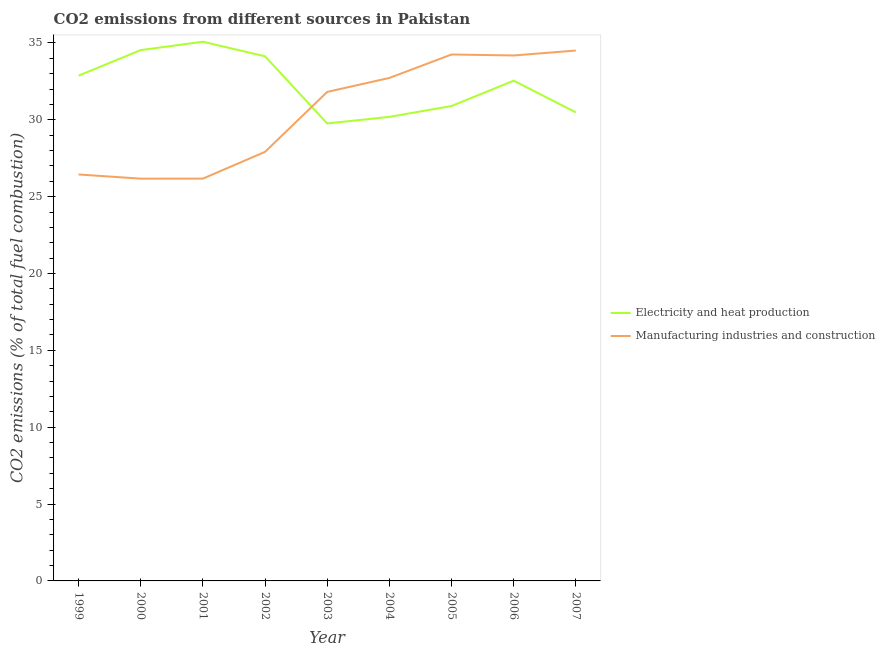How many different coloured lines are there?
Offer a terse response. 2. Is the number of lines equal to the number of legend labels?
Keep it short and to the point. Yes. What is the co2 emissions due to manufacturing industries in 2000?
Offer a very short reply. 26.17. Across all years, what is the maximum co2 emissions due to manufacturing industries?
Provide a short and direct response. 34.51. Across all years, what is the minimum co2 emissions due to electricity and heat production?
Offer a terse response. 29.76. In which year was the co2 emissions due to manufacturing industries maximum?
Give a very brief answer. 2007. In which year was the co2 emissions due to manufacturing industries minimum?
Give a very brief answer. 2000. What is the total co2 emissions due to manufacturing industries in the graph?
Your answer should be compact. 274.18. What is the difference between the co2 emissions due to manufacturing industries in 2000 and that in 2005?
Make the answer very short. -8.08. What is the difference between the co2 emissions due to manufacturing industries in 2007 and the co2 emissions due to electricity and heat production in 2006?
Keep it short and to the point. 1.96. What is the average co2 emissions due to electricity and heat production per year?
Give a very brief answer. 32.28. In the year 2002, what is the difference between the co2 emissions due to manufacturing industries and co2 emissions due to electricity and heat production?
Your answer should be very brief. -6.22. What is the ratio of the co2 emissions due to electricity and heat production in 2001 to that in 2002?
Your answer should be very brief. 1.03. Is the co2 emissions due to manufacturing industries in 2002 less than that in 2004?
Make the answer very short. Yes. Is the difference between the co2 emissions due to manufacturing industries in 2002 and 2004 greater than the difference between the co2 emissions due to electricity and heat production in 2002 and 2004?
Give a very brief answer. No. What is the difference between the highest and the second highest co2 emissions due to manufacturing industries?
Your response must be concise. 0.26. What is the difference between the highest and the lowest co2 emissions due to manufacturing industries?
Provide a short and direct response. 8.34. Is the sum of the co2 emissions due to manufacturing industries in 1999 and 2001 greater than the maximum co2 emissions due to electricity and heat production across all years?
Your answer should be compact. Yes. Does the co2 emissions due to manufacturing industries monotonically increase over the years?
Your response must be concise. No. Is the co2 emissions due to electricity and heat production strictly greater than the co2 emissions due to manufacturing industries over the years?
Provide a succinct answer. No. Is the co2 emissions due to manufacturing industries strictly less than the co2 emissions due to electricity and heat production over the years?
Your answer should be very brief. No. What is the difference between two consecutive major ticks on the Y-axis?
Give a very brief answer. 5. What is the title of the graph?
Offer a terse response. CO2 emissions from different sources in Pakistan. Does "Working only" appear as one of the legend labels in the graph?
Give a very brief answer. No. What is the label or title of the Y-axis?
Your response must be concise. CO2 emissions (% of total fuel combustion). What is the CO2 emissions (% of total fuel combustion) of Electricity and heat production in 1999?
Offer a very short reply. 32.87. What is the CO2 emissions (% of total fuel combustion) of Manufacturing industries and construction in 1999?
Your answer should be very brief. 26.44. What is the CO2 emissions (% of total fuel combustion) in Electricity and heat production in 2000?
Your answer should be compact. 34.54. What is the CO2 emissions (% of total fuel combustion) of Manufacturing industries and construction in 2000?
Provide a succinct answer. 26.17. What is the CO2 emissions (% of total fuel combustion) of Electricity and heat production in 2001?
Provide a succinct answer. 35.08. What is the CO2 emissions (% of total fuel combustion) in Manufacturing industries and construction in 2001?
Make the answer very short. 26.17. What is the CO2 emissions (% of total fuel combustion) of Electricity and heat production in 2002?
Provide a short and direct response. 34.13. What is the CO2 emissions (% of total fuel combustion) in Manufacturing industries and construction in 2002?
Your answer should be very brief. 27.91. What is the CO2 emissions (% of total fuel combustion) of Electricity and heat production in 2003?
Make the answer very short. 29.76. What is the CO2 emissions (% of total fuel combustion) in Manufacturing industries and construction in 2003?
Make the answer very short. 31.81. What is the CO2 emissions (% of total fuel combustion) in Electricity and heat production in 2004?
Offer a very short reply. 30.19. What is the CO2 emissions (% of total fuel combustion) of Manufacturing industries and construction in 2004?
Offer a very short reply. 32.72. What is the CO2 emissions (% of total fuel combustion) of Electricity and heat production in 2005?
Your answer should be very brief. 30.9. What is the CO2 emissions (% of total fuel combustion) of Manufacturing industries and construction in 2005?
Your answer should be compact. 34.25. What is the CO2 emissions (% of total fuel combustion) of Electricity and heat production in 2006?
Your answer should be compact. 32.55. What is the CO2 emissions (% of total fuel combustion) of Manufacturing industries and construction in 2006?
Keep it short and to the point. 34.19. What is the CO2 emissions (% of total fuel combustion) in Electricity and heat production in 2007?
Provide a short and direct response. 30.48. What is the CO2 emissions (% of total fuel combustion) in Manufacturing industries and construction in 2007?
Your answer should be very brief. 34.51. Across all years, what is the maximum CO2 emissions (% of total fuel combustion) in Electricity and heat production?
Make the answer very short. 35.08. Across all years, what is the maximum CO2 emissions (% of total fuel combustion) of Manufacturing industries and construction?
Provide a succinct answer. 34.51. Across all years, what is the minimum CO2 emissions (% of total fuel combustion) of Electricity and heat production?
Provide a succinct answer. 29.76. Across all years, what is the minimum CO2 emissions (% of total fuel combustion) of Manufacturing industries and construction?
Ensure brevity in your answer.  26.17. What is the total CO2 emissions (% of total fuel combustion) of Electricity and heat production in the graph?
Your response must be concise. 290.5. What is the total CO2 emissions (% of total fuel combustion) in Manufacturing industries and construction in the graph?
Your answer should be very brief. 274.18. What is the difference between the CO2 emissions (% of total fuel combustion) in Electricity and heat production in 1999 and that in 2000?
Provide a short and direct response. -1.66. What is the difference between the CO2 emissions (% of total fuel combustion) of Manufacturing industries and construction in 1999 and that in 2000?
Ensure brevity in your answer.  0.27. What is the difference between the CO2 emissions (% of total fuel combustion) in Electricity and heat production in 1999 and that in 2001?
Your answer should be compact. -2.21. What is the difference between the CO2 emissions (% of total fuel combustion) of Manufacturing industries and construction in 1999 and that in 2001?
Offer a terse response. 0.27. What is the difference between the CO2 emissions (% of total fuel combustion) of Electricity and heat production in 1999 and that in 2002?
Your response must be concise. -1.26. What is the difference between the CO2 emissions (% of total fuel combustion) of Manufacturing industries and construction in 1999 and that in 2002?
Provide a succinct answer. -1.47. What is the difference between the CO2 emissions (% of total fuel combustion) in Electricity and heat production in 1999 and that in 2003?
Make the answer very short. 3.11. What is the difference between the CO2 emissions (% of total fuel combustion) of Manufacturing industries and construction in 1999 and that in 2003?
Keep it short and to the point. -5.37. What is the difference between the CO2 emissions (% of total fuel combustion) in Electricity and heat production in 1999 and that in 2004?
Provide a succinct answer. 2.68. What is the difference between the CO2 emissions (% of total fuel combustion) in Manufacturing industries and construction in 1999 and that in 2004?
Keep it short and to the point. -6.28. What is the difference between the CO2 emissions (% of total fuel combustion) in Electricity and heat production in 1999 and that in 2005?
Give a very brief answer. 1.98. What is the difference between the CO2 emissions (% of total fuel combustion) in Manufacturing industries and construction in 1999 and that in 2005?
Make the answer very short. -7.8. What is the difference between the CO2 emissions (% of total fuel combustion) of Electricity and heat production in 1999 and that in 2006?
Offer a very short reply. 0.33. What is the difference between the CO2 emissions (% of total fuel combustion) of Manufacturing industries and construction in 1999 and that in 2006?
Offer a very short reply. -7.74. What is the difference between the CO2 emissions (% of total fuel combustion) of Electricity and heat production in 1999 and that in 2007?
Provide a short and direct response. 2.39. What is the difference between the CO2 emissions (% of total fuel combustion) of Manufacturing industries and construction in 1999 and that in 2007?
Your response must be concise. -8.06. What is the difference between the CO2 emissions (% of total fuel combustion) of Electricity and heat production in 2000 and that in 2001?
Keep it short and to the point. -0.54. What is the difference between the CO2 emissions (% of total fuel combustion) in Manufacturing industries and construction in 2000 and that in 2001?
Provide a short and direct response. -0. What is the difference between the CO2 emissions (% of total fuel combustion) of Electricity and heat production in 2000 and that in 2002?
Your response must be concise. 0.4. What is the difference between the CO2 emissions (% of total fuel combustion) of Manufacturing industries and construction in 2000 and that in 2002?
Keep it short and to the point. -1.74. What is the difference between the CO2 emissions (% of total fuel combustion) of Electricity and heat production in 2000 and that in 2003?
Offer a very short reply. 4.77. What is the difference between the CO2 emissions (% of total fuel combustion) in Manufacturing industries and construction in 2000 and that in 2003?
Make the answer very short. -5.64. What is the difference between the CO2 emissions (% of total fuel combustion) of Electricity and heat production in 2000 and that in 2004?
Offer a very short reply. 4.34. What is the difference between the CO2 emissions (% of total fuel combustion) in Manufacturing industries and construction in 2000 and that in 2004?
Your answer should be compact. -6.55. What is the difference between the CO2 emissions (% of total fuel combustion) of Electricity and heat production in 2000 and that in 2005?
Your response must be concise. 3.64. What is the difference between the CO2 emissions (% of total fuel combustion) in Manufacturing industries and construction in 2000 and that in 2005?
Provide a short and direct response. -8.08. What is the difference between the CO2 emissions (% of total fuel combustion) of Electricity and heat production in 2000 and that in 2006?
Keep it short and to the point. 1.99. What is the difference between the CO2 emissions (% of total fuel combustion) of Manufacturing industries and construction in 2000 and that in 2006?
Make the answer very short. -8.01. What is the difference between the CO2 emissions (% of total fuel combustion) in Electricity and heat production in 2000 and that in 2007?
Make the answer very short. 4.05. What is the difference between the CO2 emissions (% of total fuel combustion) of Manufacturing industries and construction in 2000 and that in 2007?
Offer a very short reply. -8.34. What is the difference between the CO2 emissions (% of total fuel combustion) in Electricity and heat production in 2001 and that in 2002?
Provide a succinct answer. 0.95. What is the difference between the CO2 emissions (% of total fuel combustion) in Manufacturing industries and construction in 2001 and that in 2002?
Provide a short and direct response. -1.74. What is the difference between the CO2 emissions (% of total fuel combustion) in Electricity and heat production in 2001 and that in 2003?
Provide a short and direct response. 5.32. What is the difference between the CO2 emissions (% of total fuel combustion) in Manufacturing industries and construction in 2001 and that in 2003?
Your answer should be compact. -5.64. What is the difference between the CO2 emissions (% of total fuel combustion) of Electricity and heat production in 2001 and that in 2004?
Provide a succinct answer. 4.89. What is the difference between the CO2 emissions (% of total fuel combustion) of Manufacturing industries and construction in 2001 and that in 2004?
Your answer should be compact. -6.55. What is the difference between the CO2 emissions (% of total fuel combustion) in Electricity and heat production in 2001 and that in 2005?
Offer a very short reply. 4.18. What is the difference between the CO2 emissions (% of total fuel combustion) in Manufacturing industries and construction in 2001 and that in 2005?
Your answer should be very brief. -8.08. What is the difference between the CO2 emissions (% of total fuel combustion) in Electricity and heat production in 2001 and that in 2006?
Give a very brief answer. 2.53. What is the difference between the CO2 emissions (% of total fuel combustion) in Manufacturing industries and construction in 2001 and that in 2006?
Give a very brief answer. -8.01. What is the difference between the CO2 emissions (% of total fuel combustion) of Electricity and heat production in 2001 and that in 2007?
Your answer should be very brief. 4.6. What is the difference between the CO2 emissions (% of total fuel combustion) of Manufacturing industries and construction in 2001 and that in 2007?
Offer a very short reply. -8.33. What is the difference between the CO2 emissions (% of total fuel combustion) in Electricity and heat production in 2002 and that in 2003?
Ensure brevity in your answer.  4.37. What is the difference between the CO2 emissions (% of total fuel combustion) in Manufacturing industries and construction in 2002 and that in 2003?
Offer a terse response. -3.9. What is the difference between the CO2 emissions (% of total fuel combustion) of Electricity and heat production in 2002 and that in 2004?
Offer a very short reply. 3.94. What is the difference between the CO2 emissions (% of total fuel combustion) of Manufacturing industries and construction in 2002 and that in 2004?
Your answer should be compact. -4.81. What is the difference between the CO2 emissions (% of total fuel combustion) in Electricity and heat production in 2002 and that in 2005?
Give a very brief answer. 3.23. What is the difference between the CO2 emissions (% of total fuel combustion) of Manufacturing industries and construction in 2002 and that in 2005?
Your response must be concise. -6.33. What is the difference between the CO2 emissions (% of total fuel combustion) of Electricity and heat production in 2002 and that in 2006?
Provide a succinct answer. 1.59. What is the difference between the CO2 emissions (% of total fuel combustion) of Manufacturing industries and construction in 2002 and that in 2006?
Offer a terse response. -6.27. What is the difference between the CO2 emissions (% of total fuel combustion) in Electricity and heat production in 2002 and that in 2007?
Give a very brief answer. 3.65. What is the difference between the CO2 emissions (% of total fuel combustion) in Manufacturing industries and construction in 2002 and that in 2007?
Your response must be concise. -6.59. What is the difference between the CO2 emissions (% of total fuel combustion) of Electricity and heat production in 2003 and that in 2004?
Your answer should be very brief. -0.43. What is the difference between the CO2 emissions (% of total fuel combustion) of Manufacturing industries and construction in 2003 and that in 2004?
Provide a succinct answer. -0.91. What is the difference between the CO2 emissions (% of total fuel combustion) of Electricity and heat production in 2003 and that in 2005?
Your answer should be compact. -1.13. What is the difference between the CO2 emissions (% of total fuel combustion) of Manufacturing industries and construction in 2003 and that in 2005?
Your answer should be very brief. -2.43. What is the difference between the CO2 emissions (% of total fuel combustion) in Electricity and heat production in 2003 and that in 2006?
Offer a very short reply. -2.78. What is the difference between the CO2 emissions (% of total fuel combustion) in Manufacturing industries and construction in 2003 and that in 2006?
Offer a very short reply. -2.37. What is the difference between the CO2 emissions (% of total fuel combustion) in Electricity and heat production in 2003 and that in 2007?
Make the answer very short. -0.72. What is the difference between the CO2 emissions (% of total fuel combustion) in Manufacturing industries and construction in 2003 and that in 2007?
Offer a very short reply. -2.69. What is the difference between the CO2 emissions (% of total fuel combustion) of Electricity and heat production in 2004 and that in 2005?
Offer a very short reply. -0.7. What is the difference between the CO2 emissions (% of total fuel combustion) in Manufacturing industries and construction in 2004 and that in 2005?
Your answer should be compact. -1.53. What is the difference between the CO2 emissions (% of total fuel combustion) of Electricity and heat production in 2004 and that in 2006?
Offer a very short reply. -2.35. What is the difference between the CO2 emissions (% of total fuel combustion) in Manufacturing industries and construction in 2004 and that in 2006?
Offer a terse response. -1.46. What is the difference between the CO2 emissions (% of total fuel combustion) in Electricity and heat production in 2004 and that in 2007?
Your response must be concise. -0.29. What is the difference between the CO2 emissions (% of total fuel combustion) in Manufacturing industries and construction in 2004 and that in 2007?
Your answer should be very brief. -1.78. What is the difference between the CO2 emissions (% of total fuel combustion) of Electricity and heat production in 2005 and that in 2006?
Provide a succinct answer. -1.65. What is the difference between the CO2 emissions (% of total fuel combustion) in Manufacturing industries and construction in 2005 and that in 2006?
Keep it short and to the point. 0.06. What is the difference between the CO2 emissions (% of total fuel combustion) of Electricity and heat production in 2005 and that in 2007?
Your response must be concise. 0.41. What is the difference between the CO2 emissions (% of total fuel combustion) in Manufacturing industries and construction in 2005 and that in 2007?
Provide a succinct answer. -0.26. What is the difference between the CO2 emissions (% of total fuel combustion) of Electricity and heat production in 2006 and that in 2007?
Your response must be concise. 2.06. What is the difference between the CO2 emissions (% of total fuel combustion) of Manufacturing industries and construction in 2006 and that in 2007?
Provide a succinct answer. -0.32. What is the difference between the CO2 emissions (% of total fuel combustion) of Electricity and heat production in 1999 and the CO2 emissions (% of total fuel combustion) of Manufacturing industries and construction in 2000?
Your response must be concise. 6.7. What is the difference between the CO2 emissions (% of total fuel combustion) in Electricity and heat production in 1999 and the CO2 emissions (% of total fuel combustion) in Manufacturing industries and construction in 2001?
Make the answer very short. 6.7. What is the difference between the CO2 emissions (% of total fuel combustion) of Electricity and heat production in 1999 and the CO2 emissions (% of total fuel combustion) of Manufacturing industries and construction in 2002?
Provide a short and direct response. 4.96. What is the difference between the CO2 emissions (% of total fuel combustion) of Electricity and heat production in 1999 and the CO2 emissions (% of total fuel combustion) of Manufacturing industries and construction in 2003?
Offer a terse response. 1.06. What is the difference between the CO2 emissions (% of total fuel combustion) of Electricity and heat production in 1999 and the CO2 emissions (% of total fuel combustion) of Manufacturing industries and construction in 2004?
Your answer should be compact. 0.15. What is the difference between the CO2 emissions (% of total fuel combustion) in Electricity and heat production in 1999 and the CO2 emissions (% of total fuel combustion) in Manufacturing industries and construction in 2005?
Offer a very short reply. -1.38. What is the difference between the CO2 emissions (% of total fuel combustion) of Electricity and heat production in 1999 and the CO2 emissions (% of total fuel combustion) of Manufacturing industries and construction in 2006?
Offer a very short reply. -1.31. What is the difference between the CO2 emissions (% of total fuel combustion) of Electricity and heat production in 1999 and the CO2 emissions (% of total fuel combustion) of Manufacturing industries and construction in 2007?
Your answer should be compact. -1.63. What is the difference between the CO2 emissions (% of total fuel combustion) in Electricity and heat production in 2000 and the CO2 emissions (% of total fuel combustion) in Manufacturing industries and construction in 2001?
Make the answer very short. 8.36. What is the difference between the CO2 emissions (% of total fuel combustion) in Electricity and heat production in 2000 and the CO2 emissions (% of total fuel combustion) in Manufacturing industries and construction in 2002?
Your answer should be compact. 6.62. What is the difference between the CO2 emissions (% of total fuel combustion) of Electricity and heat production in 2000 and the CO2 emissions (% of total fuel combustion) of Manufacturing industries and construction in 2003?
Provide a succinct answer. 2.72. What is the difference between the CO2 emissions (% of total fuel combustion) of Electricity and heat production in 2000 and the CO2 emissions (% of total fuel combustion) of Manufacturing industries and construction in 2004?
Keep it short and to the point. 1.81. What is the difference between the CO2 emissions (% of total fuel combustion) in Electricity and heat production in 2000 and the CO2 emissions (% of total fuel combustion) in Manufacturing industries and construction in 2005?
Provide a succinct answer. 0.29. What is the difference between the CO2 emissions (% of total fuel combustion) of Electricity and heat production in 2000 and the CO2 emissions (% of total fuel combustion) of Manufacturing industries and construction in 2006?
Your answer should be very brief. 0.35. What is the difference between the CO2 emissions (% of total fuel combustion) of Electricity and heat production in 2000 and the CO2 emissions (% of total fuel combustion) of Manufacturing industries and construction in 2007?
Ensure brevity in your answer.  0.03. What is the difference between the CO2 emissions (% of total fuel combustion) in Electricity and heat production in 2001 and the CO2 emissions (% of total fuel combustion) in Manufacturing industries and construction in 2002?
Provide a succinct answer. 7.17. What is the difference between the CO2 emissions (% of total fuel combustion) of Electricity and heat production in 2001 and the CO2 emissions (% of total fuel combustion) of Manufacturing industries and construction in 2003?
Offer a very short reply. 3.27. What is the difference between the CO2 emissions (% of total fuel combustion) in Electricity and heat production in 2001 and the CO2 emissions (% of total fuel combustion) in Manufacturing industries and construction in 2004?
Offer a terse response. 2.36. What is the difference between the CO2 emissions (% of total fuel combustion) in Electricity and heat production in 2001 and the CO2 emissions (% of total fuel combustion) in Manufacturing industries and construction in 2005?
Offer a terse response. 0.83. What is the difference between the CO2 emissions (% of total fuel combustion) in Electricity and heat production in 2001 and the CO2 emissions (% of total fuel combustion) in Manufacturing industries and construction in 2006?
Your answer should be very brief. 0.89. What is the difference between the CO2 emissions (% of total fuel combustion) of Electricity and heat production in 2001 and the CO2 emissions (% of total fuel combustion) of Manufacturing industries and construction in 2007?
Make the answer very short. 0.57. What is the difference between the CO2 emissions (% of total fuel combustion) of Electricity and heat production in 2002 and the CO2 emissions (% of total fuel combustion) of Manufacturing industries and construction in 2003?
Give a very brief answer. 2.32. What is the difference between the CO2 emissions (% of total fuel combustion) of Electricity and heat production in 2002 and the CO2 emissions (% of total fuel combustion) of Manufacturing industries and construction in 2004?
Offer a very short reply. 1.41. What is the difference between the CO2 emissions (% of total fuel combustion) in Electricity and heat production in 2002 and the CO2 emissions (% of total fuel combustion) in Manufacturing industries and construction in 2005?
Offer a terse response. -0.12. What is the difference between the CO2 emissions (% of total fuel combustion) in Electricity and heat production in 2002 and the CO2 emissions (% of total fuel combustion) in Manufacturing industries and construction in 2006?
Provide a succinct answer. -0.05. What is the difference between the CO2 emissions (% of total fuel combustion) of Electricity and heat production in 2002 and the CO2 emissions (% of total fuel combustion) of Manufacturing industries and construction in 2007?
Provide a short and direct response. -0.38. What is the difference between the CO2 emissions (% of total fuel combustion) in Electricity and heat production in 2003 and the CO2 emissions (% of total fuel combustion) in Manufacturing industries and construction in 2004?
Give a very brief answer. -2.96. What is the difference between the CO2 emissions (% of total fuel combustion) in Electricity and heat production in 2003 and the CO2 emissions (% of total fuel combustion) in Manufacturing industries and construction in 2005?
Keep it short and to the point. -4.49. What is the difference between the CO2 emissions (% of total fuel combustion) of Electricity and heat production in 2003 and the CO2 emissions (% of total fuel combustion) of Manufacturing industries and construction in 2006?
Make the answer very short. -4.42. What is the difference between the CO2 emissions (% of total fuel combustion) of Electricity and heat production in 2003 and the CO2 emissions (% of total fuel combustion) of Manufacturing industries and construction in 2007?
Ensure brevity in your answer.  -4.74. What is the difference between the CO2 emissions (% of total fuel combustion) in Electricity and heat production in 2004 and the CO2 emissions (% of total fuel combustion) in Manufacturing industries and construction in 2005?
Ensure brevity in your answer.  -4.06. What is the difference between the CO2 emissions (% of total fuel combustion) in Electricity and heat production in 2004 and the CO2 emissions (% of total fuel combustion) in Manufacturing industries and construction in 2006?
Offer a terse response. -3.99. What is the difference between the CO2 emissions (% of total fuel combustion) in Electricity and heat production in 2004 and the CO2 emissions (% of total fuel combustion) in Manufacturing industries and construction in 2007?
Offer a very short reply. -4.32. What is the difference between the CO2 emissions (% of total fuel combustion) of Electricity and heat production in 2005 and the CO2 emissions (% of total fuel combustion) of Manufacturing industries and construction in 2006?
Ensure brevity in your answer.  -3.29. What is the difference between the CO2 emissions (% of total fuel combustion) of Electricity and heat production in 2005 and the CO2 emissions (% of total fuel combustion) of Manufacturing industries and construction in 2007?
Provide a short and direct response. -3.61. What is the difference between the CO2 emissions (% of total fuel combustion) of Electricity and heat production in 2006 and the CO2 emissions (% of total fuel combustion) of Manufacturing industries and construction in 2007?
Provide a short and direct response. -1.96. What is the average CO2 emissions (% of total fuel combustion) of Electricity and heat production per year?
Provide a succinct answer. 32.28. What is the average CO2 emissions (% of total fuel combustion) of Manufacturing industries and construction per year?
Your response must be concise. 30.46. In the year 1999, what is the difference between the CO2 emissions (% of total fuel combustion) of Electricity and heat production and CO2 emissions (% of total fuel combustion) of Manufacturing industries and construction?
Offer a terse response. 6.43. In the year 2000, what is the difference between the CO2 emissions (% of total fuel combustion) in Electricity and heat production and CO2 emissions (% of total fuel combustion) in Manufacturing industries and construction?
Make the answer very short. 8.36. In the year 2001, what is the difference between the CO2 emissions (% of total fuel combustion) of Electricity and heat production and CO2 emissions (% of total fuel combustion) of Manufacturing industries and construction?
Your answer should be compact. 8.91. In the year 2002, what is the difference between the CO2 emissions (% of total fuel combustion) in Electricity and heat production and CO2 emissions (% of total fuel combustion) in Manufacturing industries and construction?
Provide a succinct answer. 6.22. In the year 2003, what is the difference between the CO2 emissions (% of total fuel combustion) in Electricity and heat production and CO2 emissions (% of total fuel combustion) in Manufacturing industries and construction?
Provide a succinct answer. -2.05. In the year 2004, what is the difference between the CO2 emissions (% of total fuel combustion) in Electricity and heat production and CO2 emissions (% of total fuel combustion) in Manufacturing industries and construction?
Ensure brevity in your answer.  -2.53. In the year 2005, what is the difference between the CO2 emissions (% of total fuel combustion) of Electricity and heat production and CO2 emissions (% of total fuel combustion) of Manufacturing industries and construction?
Ensure brevity in your answer.  -3.35. In the year 2006, what is the difference between the CO2 emissions (% of total fuel combustion) of Electricity and heat production and CO2 emissions (% of total fuel combustion) of Manufacturing industries and construction?
Provide a short and direct response. -1.64. In the year 2007, what is the difference between the CO2 emissions (% of total fuel combustion) of Electricity and heat production and CO2 emissions (% of total fuel combustion) of Manufacturing industries and construction?
Give a very brief answer. -4.02. What is the ratio of the CO2 emissions (% of total fuel combustion) of Electricity and heat production in 1999 to that in 2000?
Your answer should be compact. 0.95. What is the ratio of the CO2 emissions (% of total fuel combustion) in Manufacturing industries and construction in 1999 to that in 2000?
Your answer should be very brief. 1.01. What is the ratio of the CO2 emissions (% of total fuel combustion) of Electricity and heat production in 1999 to that in 2001?
Ensure brevity in your answer.  0.94. What is the ratio of the CO2 emissions (% of total fuel combustion) of Manufacturing industries and construction in 1999 to that in 2001?
Offer a terse response. 1.01. What is the ratio of the CO2 emissions (% of total fuel combustion) in Electricity and heat production in 1999 to that in 2002?
Your response must be concise. 0.96. What is the ratio of the CO2 emissions (% of total fuel combustion) in Manufacturing industries and construction in 1999 to that in 2002?
Offer a very short reply. 0.95. What is the ratio of the CO2 emissions (% of total fuel combustion) in Electricity and heat production in 1999 to that in 2003?
Make the answer very short. 1.1. What is the ratio of the CO2 emissions (% of total fuel combustion) of Manufacturing industries and construction in 1999 to that in 2003?
Offer a terse response. 0.83. What is the ratio of the CO2 emissions (% of total fuel combustion) of Electricity and heat production in 1999 to that in 2004?
Give a very brief answer. 1.09. What is the ratio of the CO2 emissions (% of total fuel combustion) of Manufacturing industries and construction in 1999 to that in 2004?
Make the answer very short. 0.81. What is the ratio of the CO2 emissions (% of total fuel combustion) in Electricity and heat production in 1999 to that in 2005?
Offer a terse response. 1.06. What is the ratio of the CO2 emissions (% of total fuel combustion) of Manufacturing industries and construction in 1999 to that in 2005?
Ensure brevity in your answer.  0.77. What is the ratio of the CO2 emissions (% of total fuel combustion) in Electricity and heat production in 1999 to that in 2006?
Offer a very short reply. 1.01. What is the ratio of the CO2 emissions (% of total fuel combustion) of Manufacturing industries and construction in 1999 to that in 2006?
Keep it short and to the point. 0.77. What is the ratio of the CO2 emissions (% of total fuel combustion) in Electricity and heat production in 1999 to that in 2007?
Your answer should be compact. 1.08. What is the ratio of the CO2 emissions (% of total fuel combustion) of Manufacturing industries and construction in 1999 to that in 2007?
Offer a terse response. 0.77. What is the ratio of the CO2 emissions (% of total fuel combustion) in Electricity and heat production in 2000 to that in 2001?
Provide a succinct answer. 0.98. What is the ratio of the CO2 emissions (% of total fuel combustion) of Manufacturing industries and construction in 2000 to that in 2001?
Provide a succinct answer. 1. What is the ratio of the CO2 emissions (% of total fuel combustion) of Electricity and heat production in 2000 to that in 2002?
Provide a succinct answer. 1.01. What is the ratio of the CO2 emissions (% of total fuel combustion) in Manufacturing industries and construction in 2000 to that in 2002?
Give a very brief answer. 0.94. What is the ratio of the CO2 emissions (% of total fuel combustion) in Electricity and heat production in 2000 to that in 2003?
Make the answer very short. 1.16. What is the ratio of the CO2 emissions (% of total fuel combustion) of Manufacturing industries and construction in 2000 to that in 2003?
Your answer should be compact. 0.82. What is the ratio of the CO2 emissions (% of total fuel combustion) of Electricity and heat production in 2000 to that in 2004?
Provide a succinct answer. 1.14. What is the ratio of the CO2 emissions (% of total fuel combustion) in Manufacturing industries and construction in 2000 to that in 2004?
Give a very brief answer. 0.8. What is the ratio of the CO2 emissions (% of total fuel combustion) in Electricity and heat production in 2000 to that in 2005?
Your response must be concise. 1.12. What is the ratio of the CO2 emissions (% of total fuel combustion) in Manufacturing industries and construction in 2000 to that in 2005?
Make the answer very short. 0.76. What is the ratio of the CO2 emissions (% of total fuel combustion) of Electricity and heat production in 2000 to that in 2006?
Keep it short and to the point. 1.06. What is the ratio of the CO2 emissions (% of total fuel combustion) in Manufacturing industries and construction in 2000 to that in 2006?
Keep it short and to the point. 0.77. What is the ratio of the CO2 emissions (% of total fuel combustion) of Electricity and heat production in 2000 to that in 2007?
Keep it short and to the point. 1.13. What is the ratio of the CO2 emissions (% of total fuel combustion) of Manufacturing industries and construction in 2000 to that in 2007?
Offer a terse response. 0.76. What is the ratio of the CO2 emissions (% of total fuel combustion) in Electricity and heat production in 2001 to that in 2002?
Ensure brevity in your answer.  1.03. What is the ratio of the CO2 emissions (% of total fuel combustion) of Manufacturing industries and construction in 2001 to that in 2002?
Your response must be concise. 0.94. What is the ratio of the CO2 emissions (% of total fuel combustion) of Electricity and heat production in 2001 to that in 2003?
Give a very brief answer. 1.18. What is the ratio of the CO2 emissions (% of total fuel combustion) in Manufacturing industries and construction in 2001 to that in 2003?
Give a very brief answer. 0.82. What is the ratio of the CO2 emissions (% of total fuel combustion) in Electricity and heat production in 2001 to that in 2004?
Provide a short and direct response. 1.16. What is the ratio of the CO2 emissions (% of total fuel combustion) in Manufacturing industries and construction in 2001 to that in 2004?
Provide a short and direct response. 0.8. What is the ratio of the CO2 emissions (% of total fuel combustion) of Electricity and heat production in 2001 to that in 2005?
Offer a terse response. 1.14. What is the ratio of the CO2 emissions (% of total fuel combustion) of Manufacturing industries and construction in 2001 to that in 2005?
Your answer should be compact. 0.76. What is the ratio of the CO2 emissions (% of total fuel combustion) of Electricity and heat production in 2001 to that in 2006?
Provide a succinct answer. 1.08. What is the ratio of the CO2 emissions (% of total fuel combustion) in Manufacturing industries and construction in 2001 to that in 2006?
Provide a short and direct response. 0.77. What is the ratio of the CO2 emissions (% of total fuel combustion) in Electricity and heat production in 2001 to that in 2007?
Provide a succinct answer. 1.15. What is the ratio of the CO2 emissions (% of total fuel combustion) of Manufacturing industries and construction in 2001 to that in 2007?
Keep it short and to the point. 0.76. What is the ratio of the CO2 emissions (% of total fuel combustion) of Electricity and heat production in 2002 to that in 2003?
Your answer should be very brief. 1.15. What is the ratio of the CO2 emissions (% of total fuel combustion) in Manufacturing industries and construction in 2002 to that in 2003?
Provide a succinct answer. 0.88. What is the ratio of the CO2 emissions (% of total fuel combustion) in Electricity and heat production in 2002 to that in 2004?
Ensure brevity in your answer.  1.13. What is the ratio of the CO2 emissions (% of total fuel combustion) of Manufacturing industries and construction in 2002 to that in 2004?
Your answer should be compact. 0.85. What is the ratio of the CO2 emissions (% of total fuel combustion) of Electricity and heat production in 2002 to that in 2005?
Your response must be concise. 1.1. What is the ratio of the CO2 emissions (% of total fuel combustion) of Manufacturing industries and construction in 2002 to that in 2005?
Offer a very short reply. 0.81. What is the ratio of the CO2 emissions (% of total fuel combustion) in Electricity and heat production in 2002 to that in 2006?
Give a very brief answer. 1.05. What is the ratio of the CO2 emissions (% of total fuel combustion) in Manufacturing industries and construction in 2002 to that in 2006?
Keep it short and to the point. 0.82. What is the ratio of the CO2 emissions (% of total fuel combustion) in Electricity and heat production in 2002 to that in 2007?
Your answer should be compact. 1.12. What is the ratio of the CO2 emissions (% of total fuel combustion) of Manufacturing industries and construction in 2002 to that in 2007?
Offer a terse response. 0.81. What is the ratio of the CO2 emissions (% of total fuel combustion) of Electricity and heat production in 2003 to that in 2004?
Provide a short and direct response. 0.99. What is the ratio of the CO2 emissions (% of total fuel combustion) of Manufacturing industries and construction in 2003 to that in 2004?
Give a very brief answer. 0.97. What is the ratio of the CO2 emissions (% of total fuel combustion) in Electricity and heat production in 2003 to that in 2005?
Give a very brief answer. 0.96. What is the ratio of the CO2 emissions (% of total fuel combustion) of Manufacturing industries and construction in 2003 to that in 2005?
Ensure brevity in your answer.  0.93. What is the ratio of the CO2 emissions (% of total fuel combustion) in Electricity and heat production in 2003 to that in 2006?
Give a very brief answer. 0.91. What is the ratio of the CO2 emissions (% of total fuel combustion) of Manufacturing industries and construction in 2003 to that in 2006?
Your answer should be compact. 0.93. What is the ratio of the CO2 emissions (% of total fuel combustion) of Electricity and heat production in 2003 to that in 2007?
Your answer should be compact. 0.98. What is the ratio of the CO2 emissions (% of total fuel combustion) in Manufacturing industries and construction in 2003 to that in 2007?
Provide a succinct answer. 0.92. What is the ratio of the CO2 emissions (% of total fuel combustion) in Electricity and heat production in 2004 to that in 2005?
Provide a succinct answer. 0.98. What is the ratio of the CO2 emissions (% of total fuel combustion) of Manufacturing industries and construction in 2004 to that in 2005?
Make the answer very short. 0.96. What is the ratio of the CO2 emissions (% of total fuel combustion) in Electricity and heat production in 2004 to that in 2006?
Offer a terse response. 0.93. What is the ratio of the CO2 emissions (% of total fuel combustion) in Manufacturing industries and construction in 2004 to that in 2006?
Provide a short and direct response. 0.96. What is the ratio of the CO2 emissions (% of total fuel combustion) in Electricity and heat production in 2004 to that in 2007?
Your answer should be compact. 0.99. What is the ratio of the CO2 emissions (% of total fuel combustion) of Manufacturing industries and construction in 2004 to that in 2007?
Offer a very short reply. 0.95. What is the ratio of the CO2 emissions (% of total fuel combustion) in Electricity and heat production in 2005 to that in 2006?
Offer a very short reply. 0.95. What is the ratio of the CO2 emissions (% of total fuel combustion) in Manufacturing industries and construction in 2005 to that in 2006?
Ensure brevity in your answer.  1. What is the ratio of the CO2 emissions (% of total fuel combustion) in Electricity and heat production in 2005 to that in 2007?
Your answer should be compact. 1.01. What is the ratio of the CO2 emissions (% of total fuel combustion) of Manufacturing industries and construction in 2005 to that in 2007?
Offer a very short reply. 0.99. What is the ratio of the CO2 emissions (% of total fuel combustion) in Electricity and heat production in 2006 to that in 2007?
Your answer should be compact. 1.07. What is the ratio of the CO2 emissions (% of total fuel combustion) of Manufacturing industries and construction in 2006 to that in 2007?
Provide a succinct answer. 0.99. What is the difference between the highest and the second highest CO2 emissions (% of total fuel combustion) in Electricity and heat production?
Provide a short and direct response. 0.54. What is the difference between the highest and the second highest CO2 emissions (% of total fuel combustion) of Manufacturing industries and construction?
Provide a short and direct response. 0.26. What is the difference between the highest and the lowest CO2 emissions (% of total fuel combustion) of Electricity and heat production?
Offer a terse response. 5.32. What is the difference between the highest and the lowest CO2 emissions (% of total fuel combustion) in Manufacturing industries and construction?
Give a very brief answer. 8.34. 